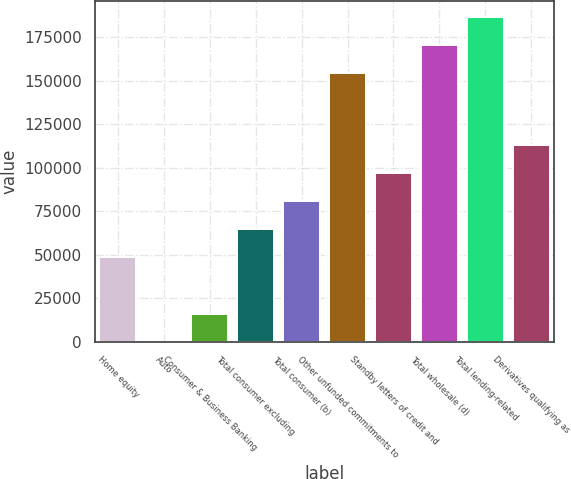<chart> <loc_0><loc_0><loc_500><loc_500><bar_chart><fcel>Home equity<fcel>Auto<fcel>Consumer & Business Banking<fcel>Total consumer excluding<fcel>Total consumer (b)<fcel>Other unfunded commitments to<fcel>Standby letters of credit and<fcel>Total wholesale (d)<fcel>Total lending-related<fcel>Derivatives qualifying as<nl><fcel>48492<fcel>78<fcel>16216<fcel>64630<fcel>80768<fcel>154177<fcel>96906<fcel>170315<fcel>186453<fcel>113044<nl></chart> 